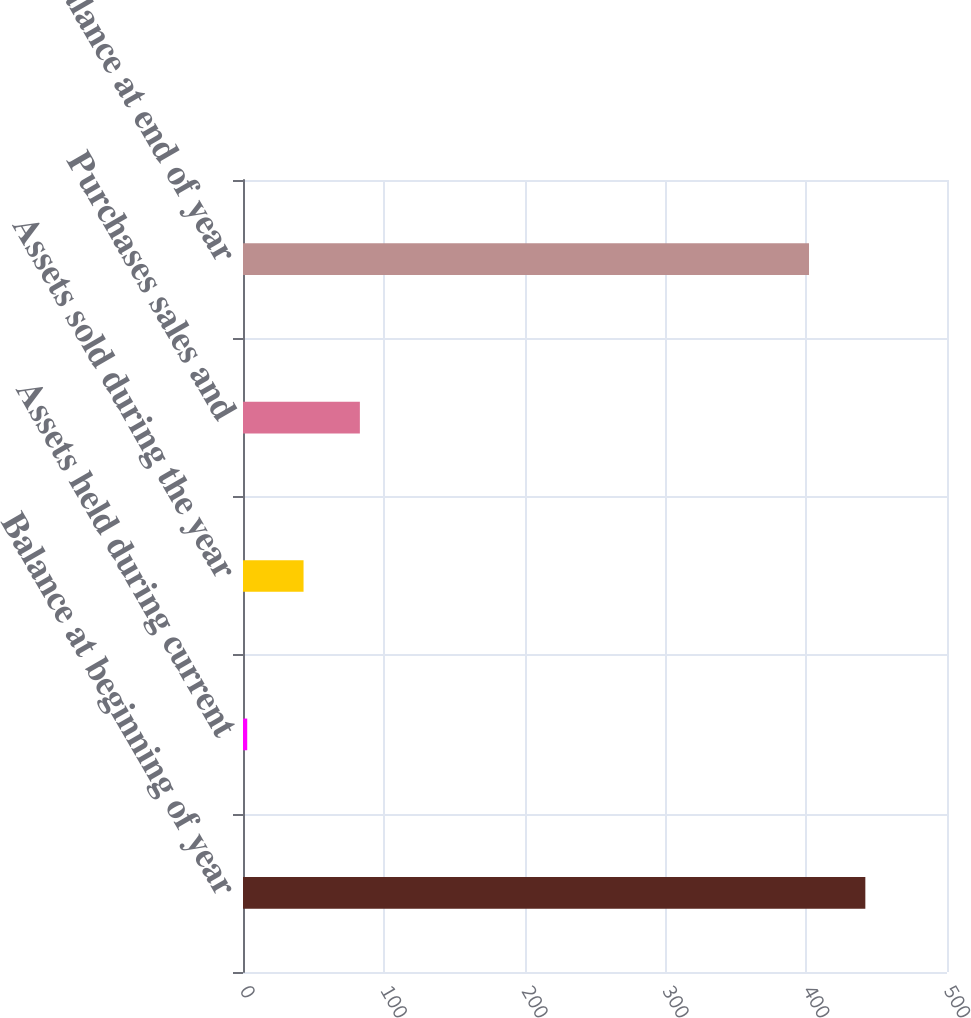Convert chart to OTSL. <chart><loc_0><loc_0><loc_500><loc_500><bar_chart><fcel>Balance at beginning of year<fcel>Assets held during current<fcel>Assets sold during the year<fcel>Purchases sales and<fcel>Balance at end of year<nl><fcel>442<fcel>3<fcel>43<fcel>83<fcel>402<nl></chart> 